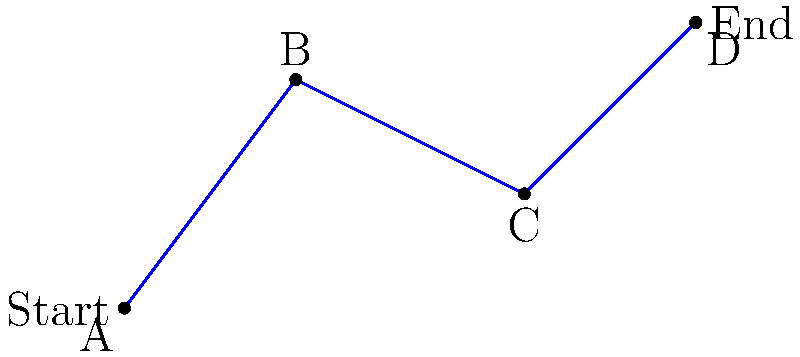Given the waypoints A(0,0), B(3,4), C(7,2), and D(10,5) for an exoskeleton leg movement, determine the total distance traveled if the leg follows a straight path between each consecutive point. Round your answer to two decimal places. To find the total distance traveled, we need to calculate the distance between each consecutive pair of points and sum them up. We can use the distance formula between two points $(x_1, y_1)$ and $(x_2, y_2)$:

$$d = \sqrt{(x_2 - x_1)^2 + (y_2 - y_1)^2}$$

Step 1: Calculate distance AB
$$AB = \sqrt{(3-0)^2 + (4-0)^2} = \sqrt{9 + 16} = \sqrt{25} = 5$$

Step 2: Calculate distance BC
$$BC = \sqrt{(7-3)^2 + (2-4)^2} = \sqrt{16 + 4} = \sqrt{20} = 2\sqrt{5} \approx 4.47$$

Step 3: Calculate distance CD
$$CD = \sqrt{(10-7)^2 + (5-2)^2} = \sqrt{9 + 9} = \sqrt{18} = 3\sqrt{2} \approx 4.24$$

Step 4: Sum up all distances
Total distance = AB + BC + CD
$$= 5 + 2\sqrt{5} + 3\sqrt{2} \approx 5 + 4.47 + 4.24 = 13.71$$

Rounding to two decimal places, we get 13.71.
Answer: 13.71 units 